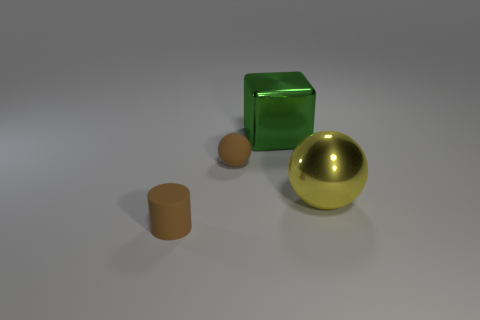Add 4 metal balls. How many objects exist? 8 Subtract all blocks. How many objects are left? 3 Add 4 metal balls. How many metal balls exist? 5 Subtract 1 brown balls. How many objects are left? 3 Subtract all small brown cylinders. Subtract all brown balls. How many objects are left? 2 Add 1 tiny rubber spheres. How many tiny rubber spheres are left? 2 